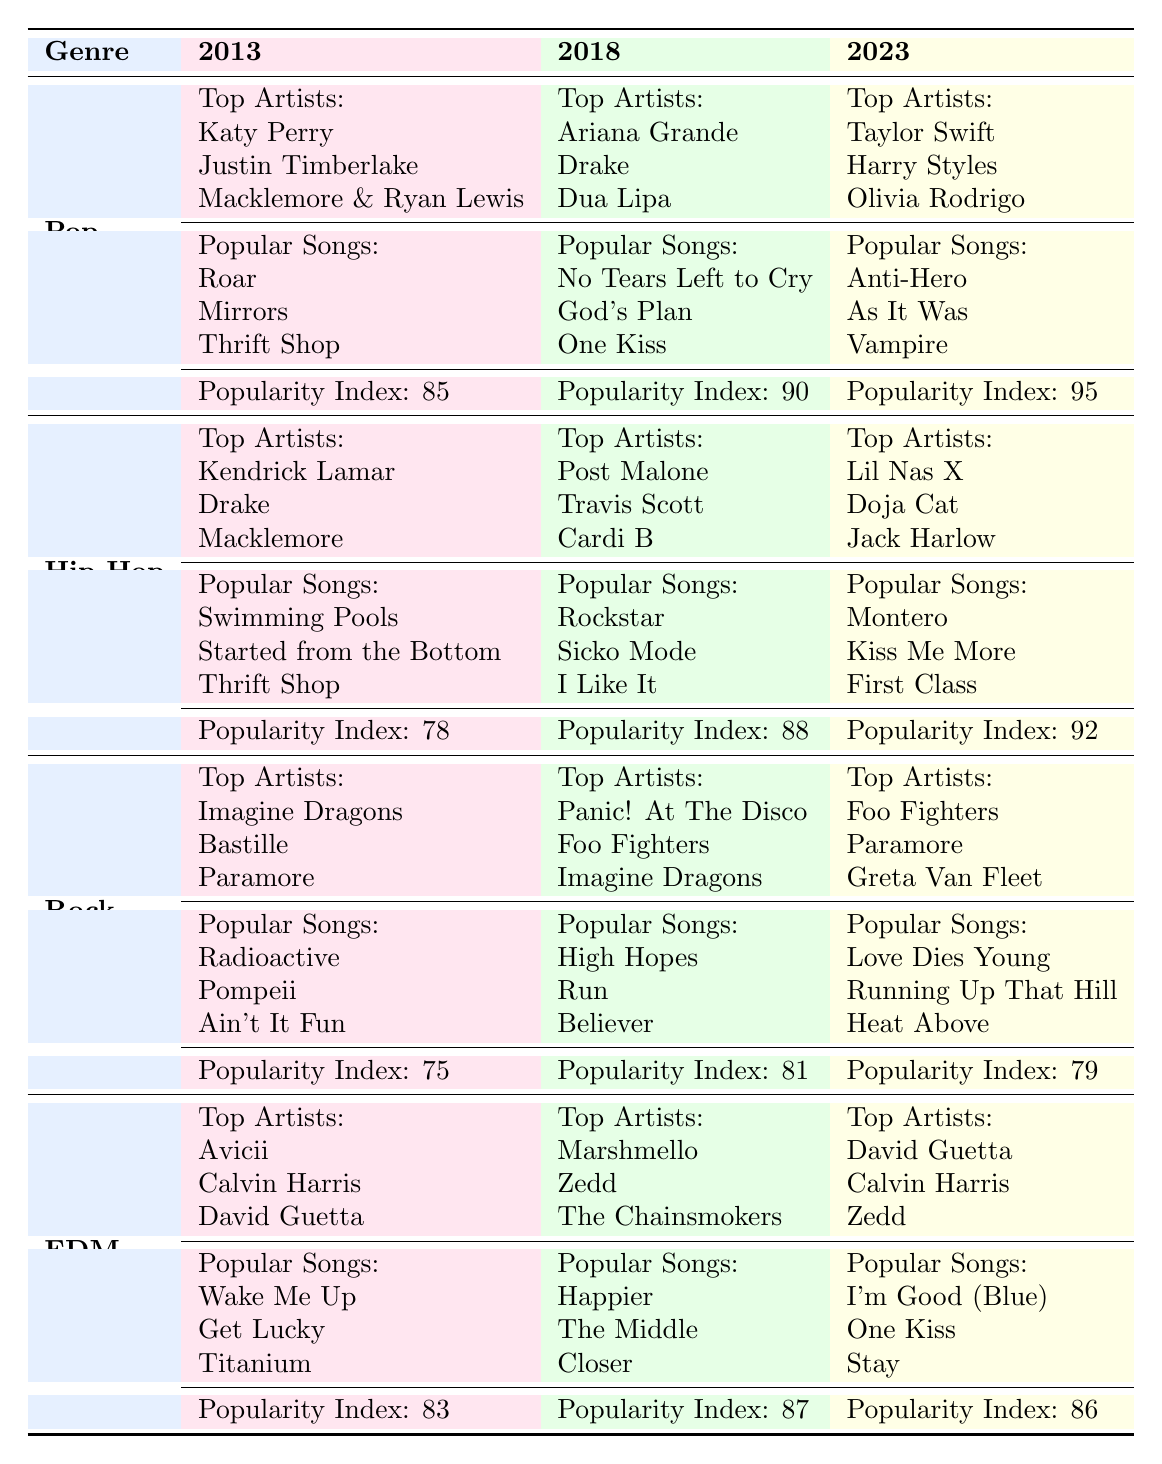What are the top artists in the Pop genre for 2023? The table shows that for Pop in 2023, the top artists are Taylor Swift, Harry Styles, and Olivia Rodrigo.
Answer: Taylor Swift, Harry Styles, Olivia Rodrigo Which genre had the highest Streaming Popularity Index in 2018? By comparing the Streaming Popularity Index values in 2018, Pop has an index of 90, Hip-Hop has 88, Rock has 81, and EDM has 87. Therefore, Pop had the highest index.
Answer: Pop What are the popular songs in Hip-Hop for 2023? The table lists the popular songs for Hip-Hop in 2023 as Montero, Kiss Me More, and First Class.
Answer: Montero, Kiss Me More, First Class Did the Streaming Popularity Index for Rock increase from 2013 to 2018? In 2013, the index was 75, and in 2018, it increased to 81, indicating an increase.
Answer: Yes What is the difference in the Streaming Popularity Index between Pop and Rock in 2023? The Streaming Popularity Index for Pop in 2023 is 95, and for Rock, it is 79. The difference is 95 - 79 = 16.
Answer: 16 What are the popular songs in the EDM genre for 2013? The popular songs in EDM for 2013 are Wake Me Up, Get Lucky, and Titanium, as listed in the table.
Answer: Wake Me Up, Get Lucky, Titanium Is Dua Lipa listed as a top artist in Hip-Hop for any year? Dua Lipa is shown as a top artist under Pop in 2018, but not under Hip-Hop in any year, which confirms that the statement is false.
Answer: No What were the top artists in Rock for 2018, and how does this compare to Pop for the same year? The top artists in Rock for 2018 are Panic! At The Disco, Foo Fighters, and Imagine Dragons, while for Pop, they are Ariana Grande, Drake, and Dua Lipa. Both genres feature prominent artists but different names.
Answer: Panic! At The Disco, Foo Fighters, Imagine Dragons; compared to Ariana Grande, Drake, Dua Lipa What is the average Streaming Popularity Index for all genres in 2023? The indexes for 2023 are 95 (Pop), 92 (Hip-Hop), 79 (Rock), and 86 (EDM). The sum is 95 + 92 + 79 + 86 = 352, and dividing by 4 gives an average of 352 / 4 = 88.
Answer: 88 